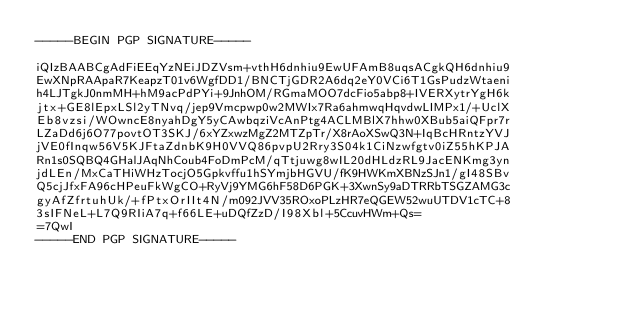<code> <loc_0><loc_0><loc_500><loc_500><_SML_>-----BEGIN PGP SIGNATURE-----

iQIzBAABCgAdFiEEqYzNEiJDZVsm+vthH6dnhiu9EwUFAmB8uqsACgkQH6dnhiu9
EwXNpRAApaR7KeapzT01v6WgfDD1/BNCTjGDR2A6dq2eY0VCi6T1GsPudzWtaeni
h4LJTgkJ0nmMH+hM9acPdPYi+9JnhOM/RGmaMOO7dcFio5abp8+IVERXytrYgH6k
jtx+GE8lEpxLSl2yTNvq/jep9Vmcpwp0w2MWIx7Ra6ahmwqHqvdwLIMPx1/+UclX
Eb8vzsi/WOwncE8nyahDgY5yCAwbqziVcAnPtg4ACLMBlX7hhw0XBub5aiQFpr7r
LZaDd6j6O77povtOT3SKJ/6xYZxwzMgZ2MTZpTr/X8rAoXSwQ3N+IqBcHRntzYVJ
jVE0fInqw56V5KJFtaZdnbK9H0VVQ86pvpU2Rry3S04k1CiNzwfgtv0iZ55hKPJA
Rn1s0SQBQ4GHalJAqNhCoub4FoDmPcM/qTtjuwg8wIL20dHLdzRL9JacENKmg3yn
jdLEn/MxCaTHiWHzTocjO5Gpkvffu1hSYmjbHGVU/fK9HWKmXBNzSJn1/gI48SBv
Q5cjJfxFA96cHPeuFkWgCO+RyVj9YMG6hF58D6PGK+3XwnSy9aDTRRbTSGZAMG3c
gyAfZfrtuhUk/+fPtxOrIIt4N/m092JVV35ROxoPLzHR7eQGEW52wuUTDV1cTC+8
3sIFNeL+L7Q9RIiA7q+f66LE+uDQfZzD/I98Xbl+5CcuvHWm+Qs=
=7QwI
-----END PGP SIGNATURE-----
</code> 